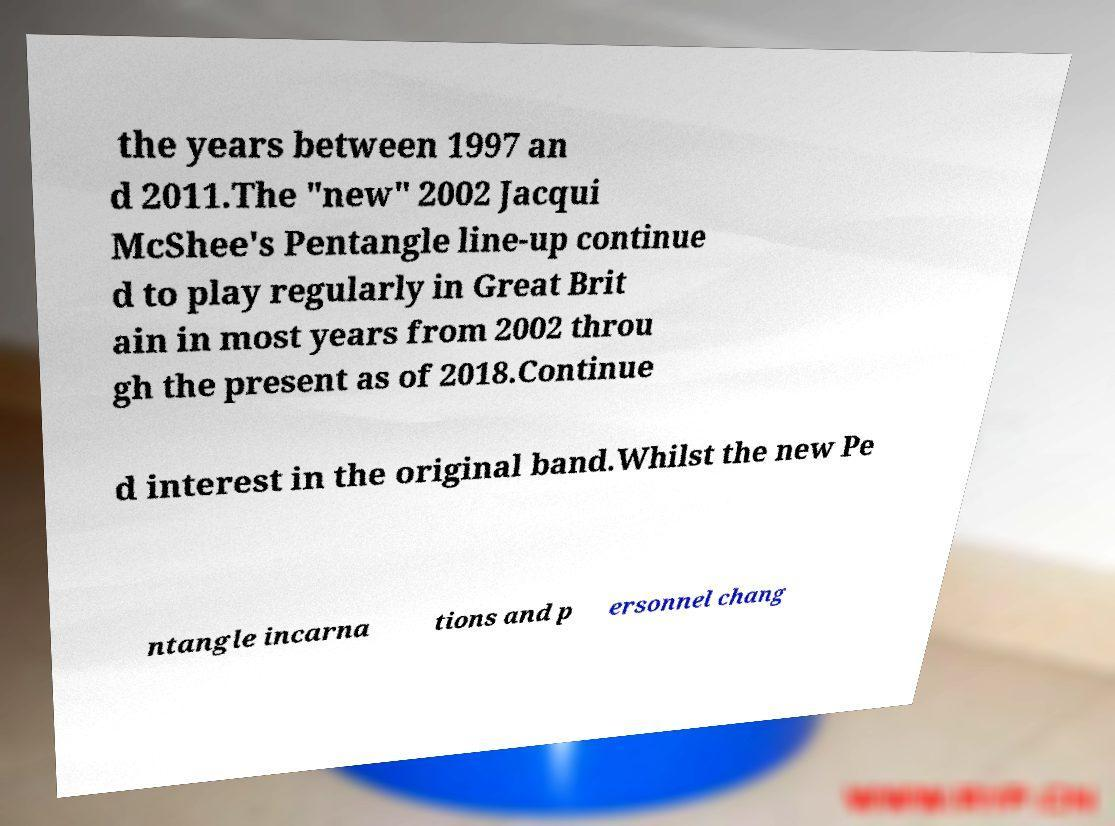Please identify and transcribe the text found in this image. the years between 1997 an d 2011.The "new" 2002 Jacqui McShee's Pentangle line-up continue d to play regularly in Great Brit ain in most years from 2002 throu gh the present as of 2018.Continue d interest in the original band.Whilst the new Pe ntangle incarna tions and p ersonnel chang 